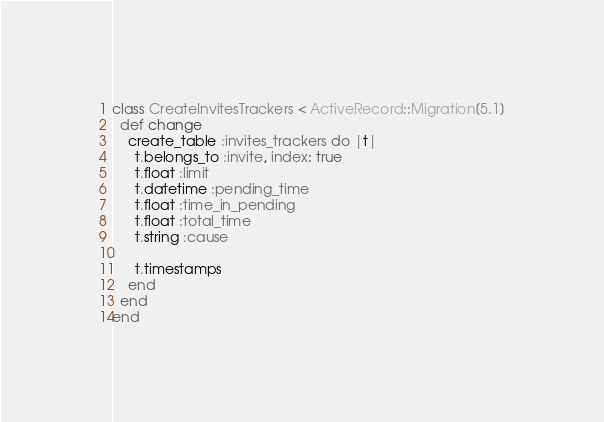<code> <loc_0><loc_0><loc_500><loc_500><_Ruby_>class CreateInvitesTrackers < ActiveRecord::Migration[5.1]
  def change
    create_table :invites_trackers do |t|
      t.belongs_to :invite, index: true
      t.float :limit
      t.datetime :pending_time
      t.float :time_in_pending
      t.float :total_time
      t.string :cause

      t.timestamps
    end
  end
end
</code> 